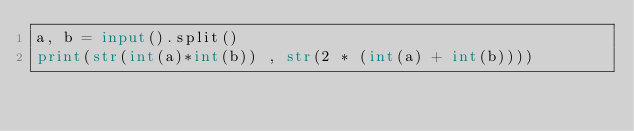Convert code to text. <code><loc_0><loc_0><loc_500><loc_500><_Python_>a, b = input().split()
print(str(int(a)*int(b)) , str(2 * (int(a) + int(b))))
</code> 